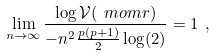<formula> <loc_0><loc_0><loc_500><loc_500>\lim _ { n \rightarrow \infty } \frac { \log \mathcal { V } ( \ m o m r ) } { - n ^ { 2 } \frac { p ( p + 1 ) } { 2 } \log ( 2 ) } = 1 \ ,</formula> 